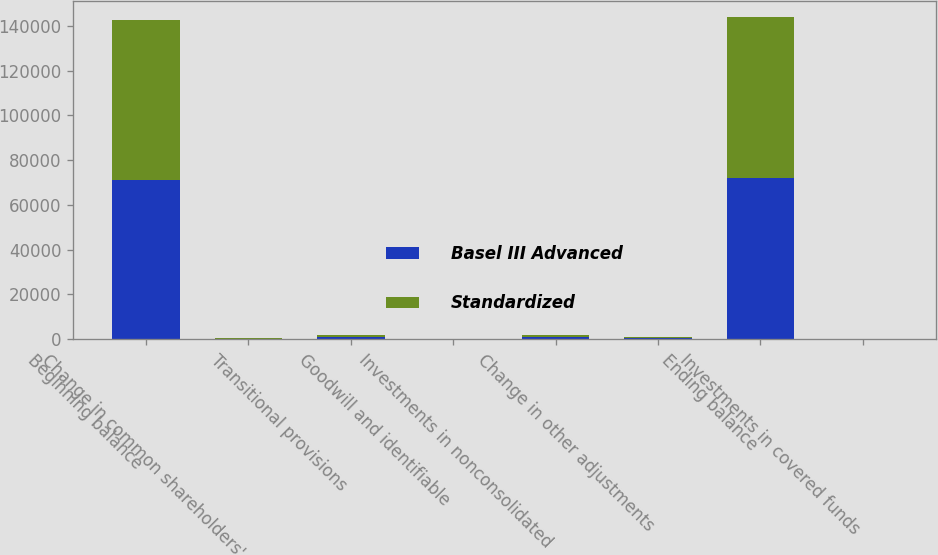Convert chart to OTSL. <chart><loc_0><loc_0><loc_500><loc_500><stacked_bar_chart><ecel><fcel>Beginning balance<fcel>Change in common shareholders'<fcel>Transitional provisions<fcel>Goodwill and identifiable<fcel>Investments in nonconsolidated<fcel>Change in other adjustments<fcel>Ending balance<fcel>Investments in covered funds<nl><fcel>Basel III Advanced<fcel>71363<fcel>162<fcel>839<fcel>16<fcel>895<fcel>449<fcel>72046<fcel>32<nl><fcel>Standardized<fcel>71363<fcel>162<fcel>839<fcel>16<fcel>895<fcel>449<fcel>72046<fcel>32<nl></chart> 